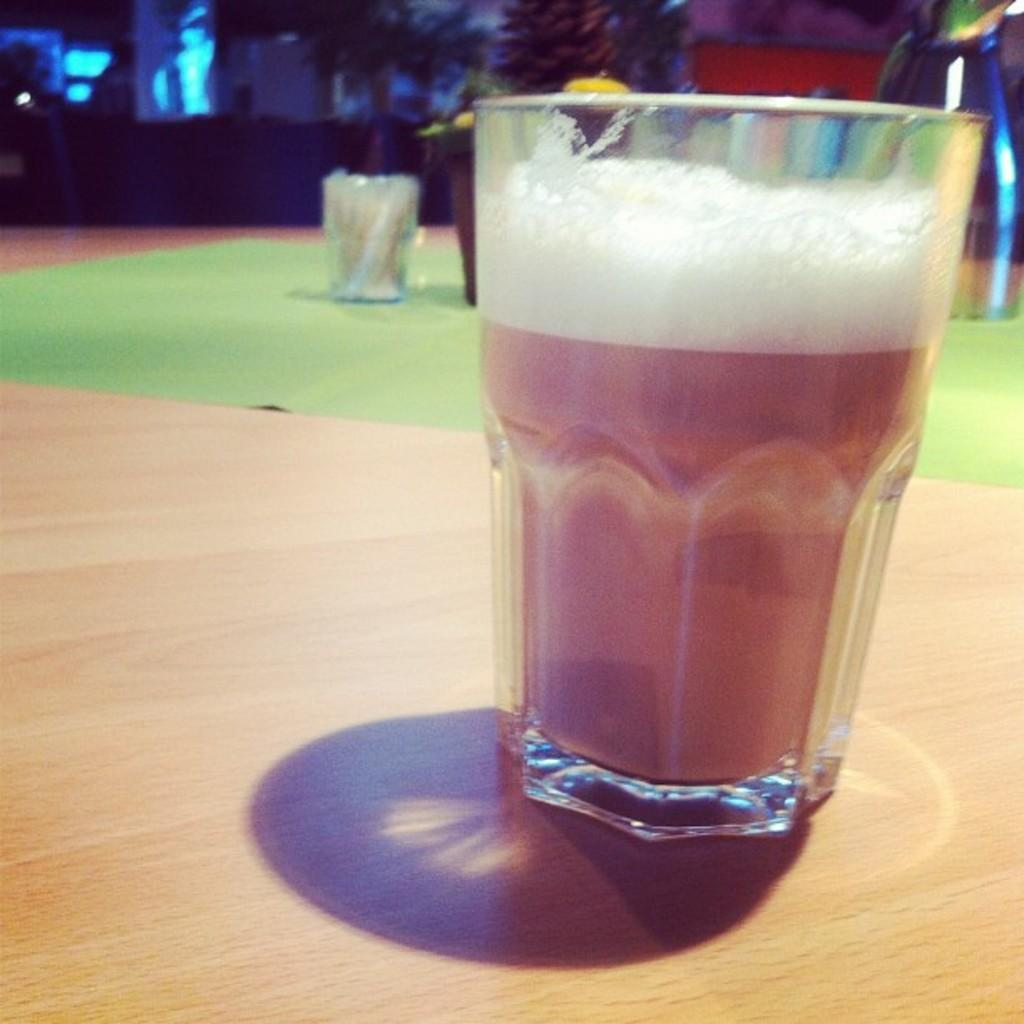What object is located on the right side of the image? There is a glass in the image, and it is on the right side. Where is the glass placed in the image? The glass is on a table in the image. What leg is visible in the image? There is no leg visible in the image; it only features a glass on a table. What type of wine is being served in the glass in the image? There is no wine present in the image; only a glass is visible. 